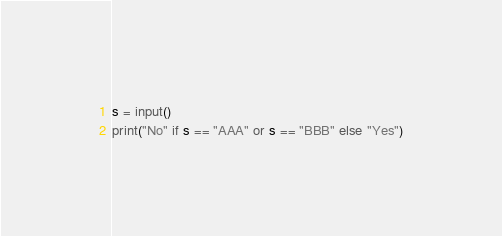<code> <loc_0><loc_0><loc_500><loc_500><_Python_>s = input()
print("No" if s == "AAA" or s == "BBB" else "Yes")</code> 